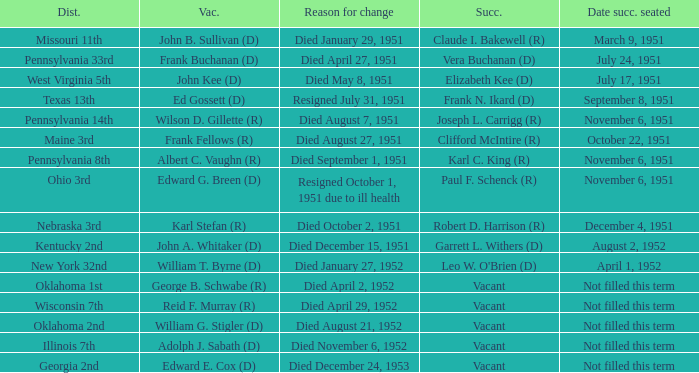Who was the successor for the Kentucky 2nd district? Garrett L. Withers (D). 